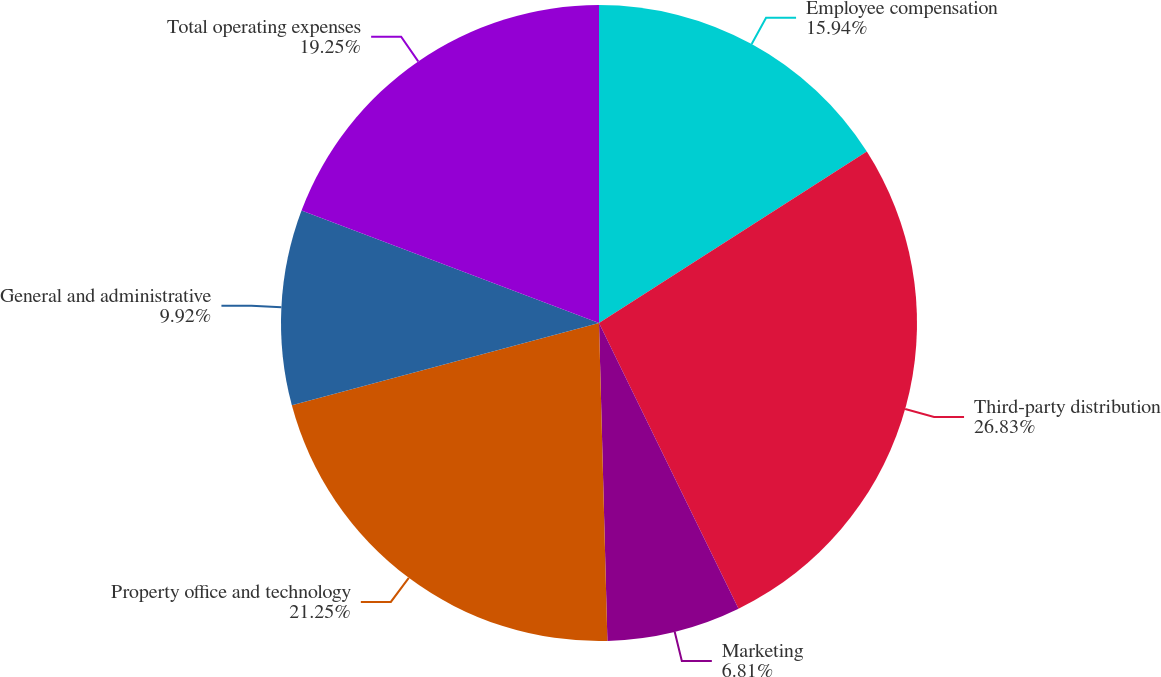Convert chart. <chart><loc_0><loc_0><loc_500><loc_500><pie_chart><fcel>Employee compensation<fcel>Third-party distribution<fcel>Marketing<fcel>Property office and technology<fcel>General and administrative<fcel>Total operating expenses<nl><fcel>15.94%<fcel>26.83%<fcel>6.81%<fcel>21.25%<fcel>9.92%<fcel>19.25%<nl></chart> 